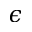<formula> <loc_0><loc_0><loc_500><loc_500>\epsilon</formula> 